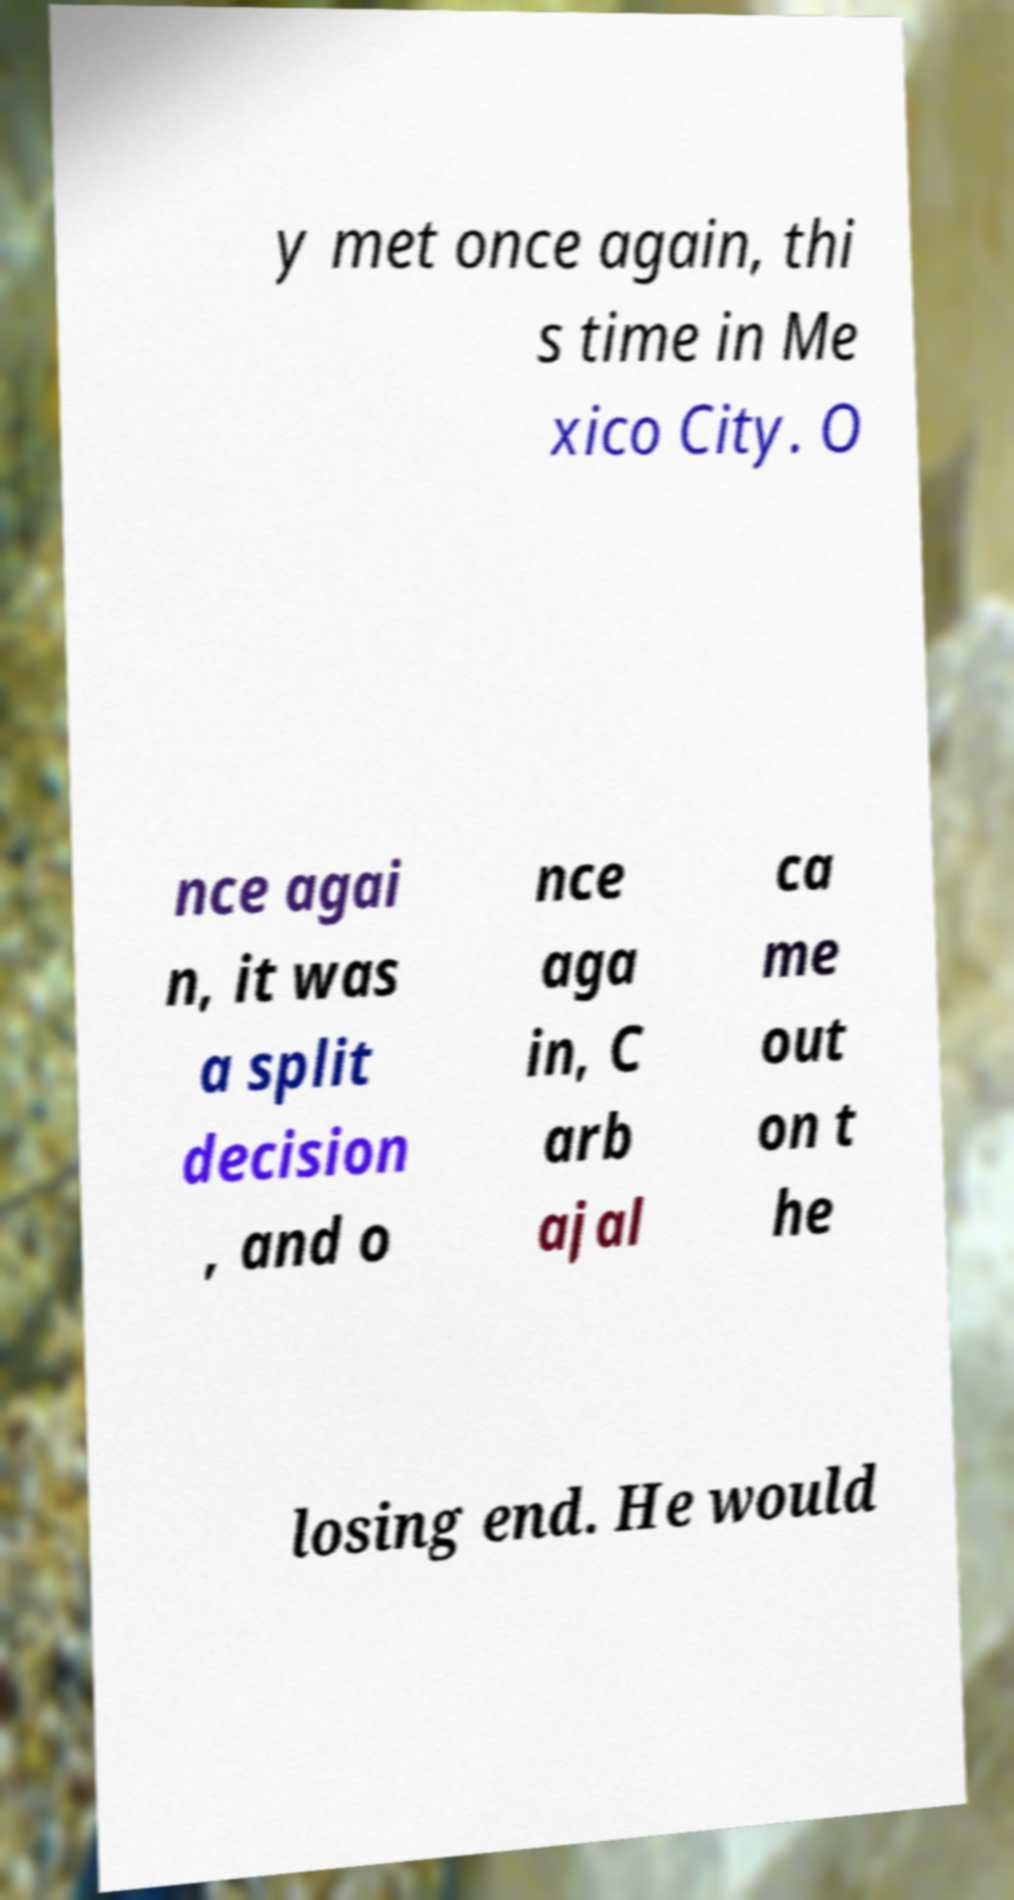There's text embedded in this image that I need extracted. Can you transcribe it verbatim? y met once again, thi s time in Me xico City. O nce agai n, it was a split decision , and o nce aga in, C arb ajal ca me out on t he losing end. He would 